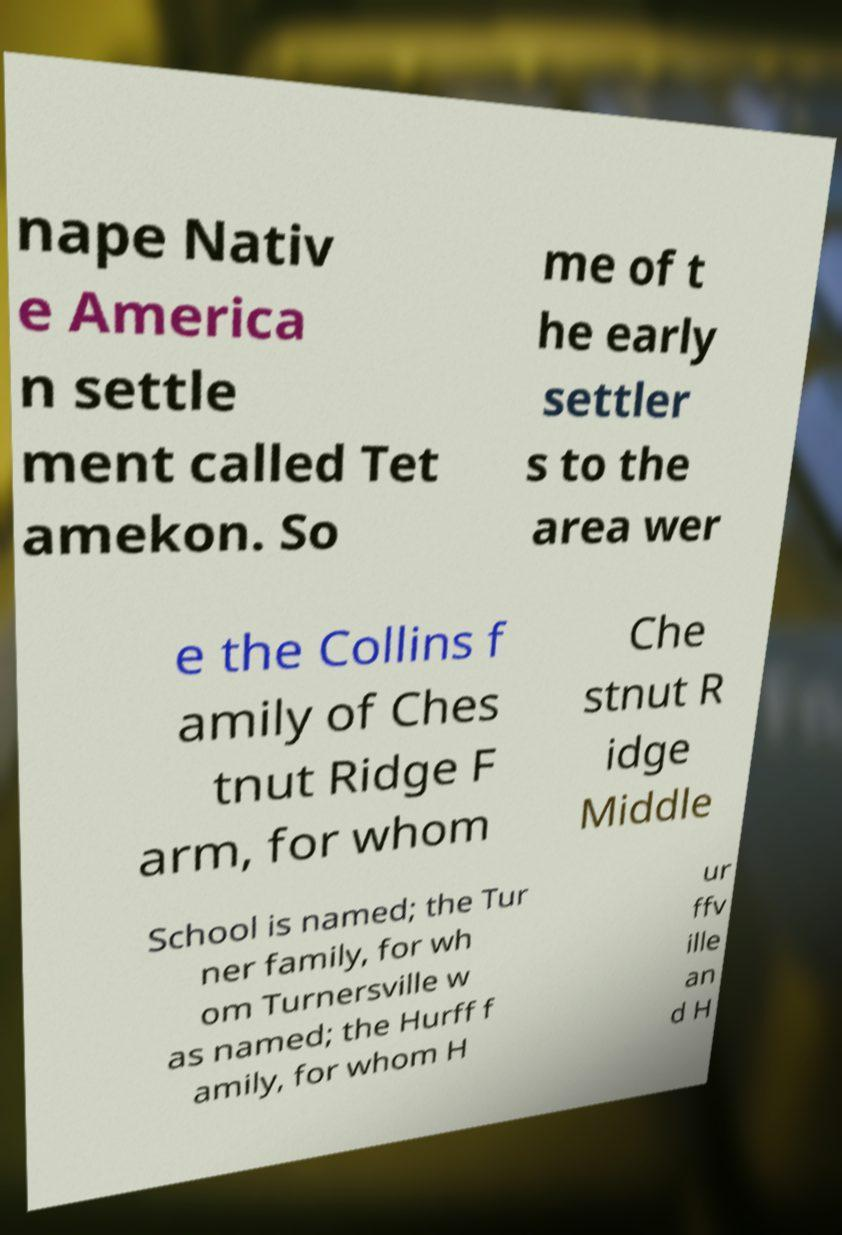For documentation purposes, I need the text within this image transcribed. Could you provide that? nape Nativ e America n settle ment called Tet amekon. So me of t he early settler s to the area wer e the Collins f amily of Ches tnut Ridge F arm, for whom Che stnut R idge Middle School is named; the Tur ner family, for wh om Turnersville w as named; the Hurff f amily, for whom H ur ffv ille an d H 